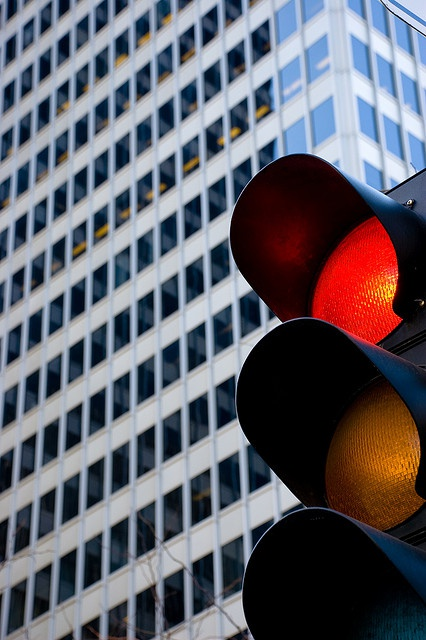Describe the objects in this image and their specific colors. I can see a traffic light in darkgray, black, maroon, red, and brown tones in this image. 